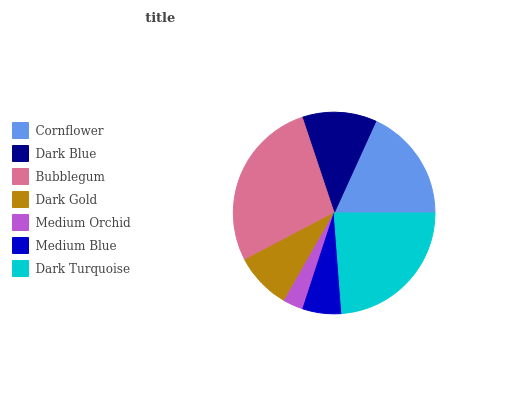Is Medium Orchid the minimum?
Answer yes or no. Yes. Is Bubblegum the maximum?
Answer yes or no. Yes. Is Dark Blue the minimum?
Answer yes or no. No. Is Dark Blue the maximum?
Answer yes or no. No. Is Cornflower greater than Dark Blue?
Answer yes or no. Yes. Is Dark Blue less than Cornflower?
Answer yes or no. Yes. Is Dark Blue greater than Cornflower?
Answer yes or no. No. Is Cornflower less than Dark Blue?
Answer yes or no. No. Is Dark Blue the high median?
Answer yes or no. Yes. Is Dark Blue the low median?
Answer yes or no. Yes. Is Dark Turquoise the high median?
Answer yes or no. No. Is Bubblegum the low median?
Answer yes or no. No. 